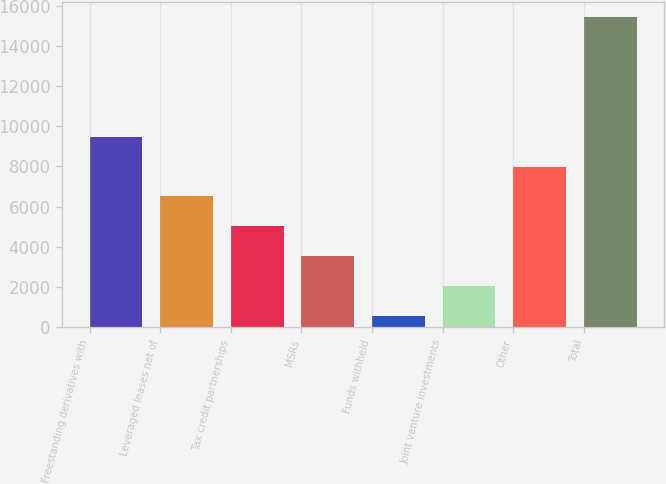Convert chart. <chart><loc_0><loc_0><loc_500><loc_500><bar_chart><fcel>Freestanding derivatives with<fcel>Leveraged leases net of<fcel>Tax credit partnerships<fcel>MSRs<fcel>Funds withheld<fcel>Joint venture investments<fcel>Other<fcel>Total<nl><fcel>9478.4<fcel>6502.6<fcel>5014.7<fcel>3526.8<fcel>551<fcel>2038.9<fcel>7990.5<fcel>15430<nl></chart> 